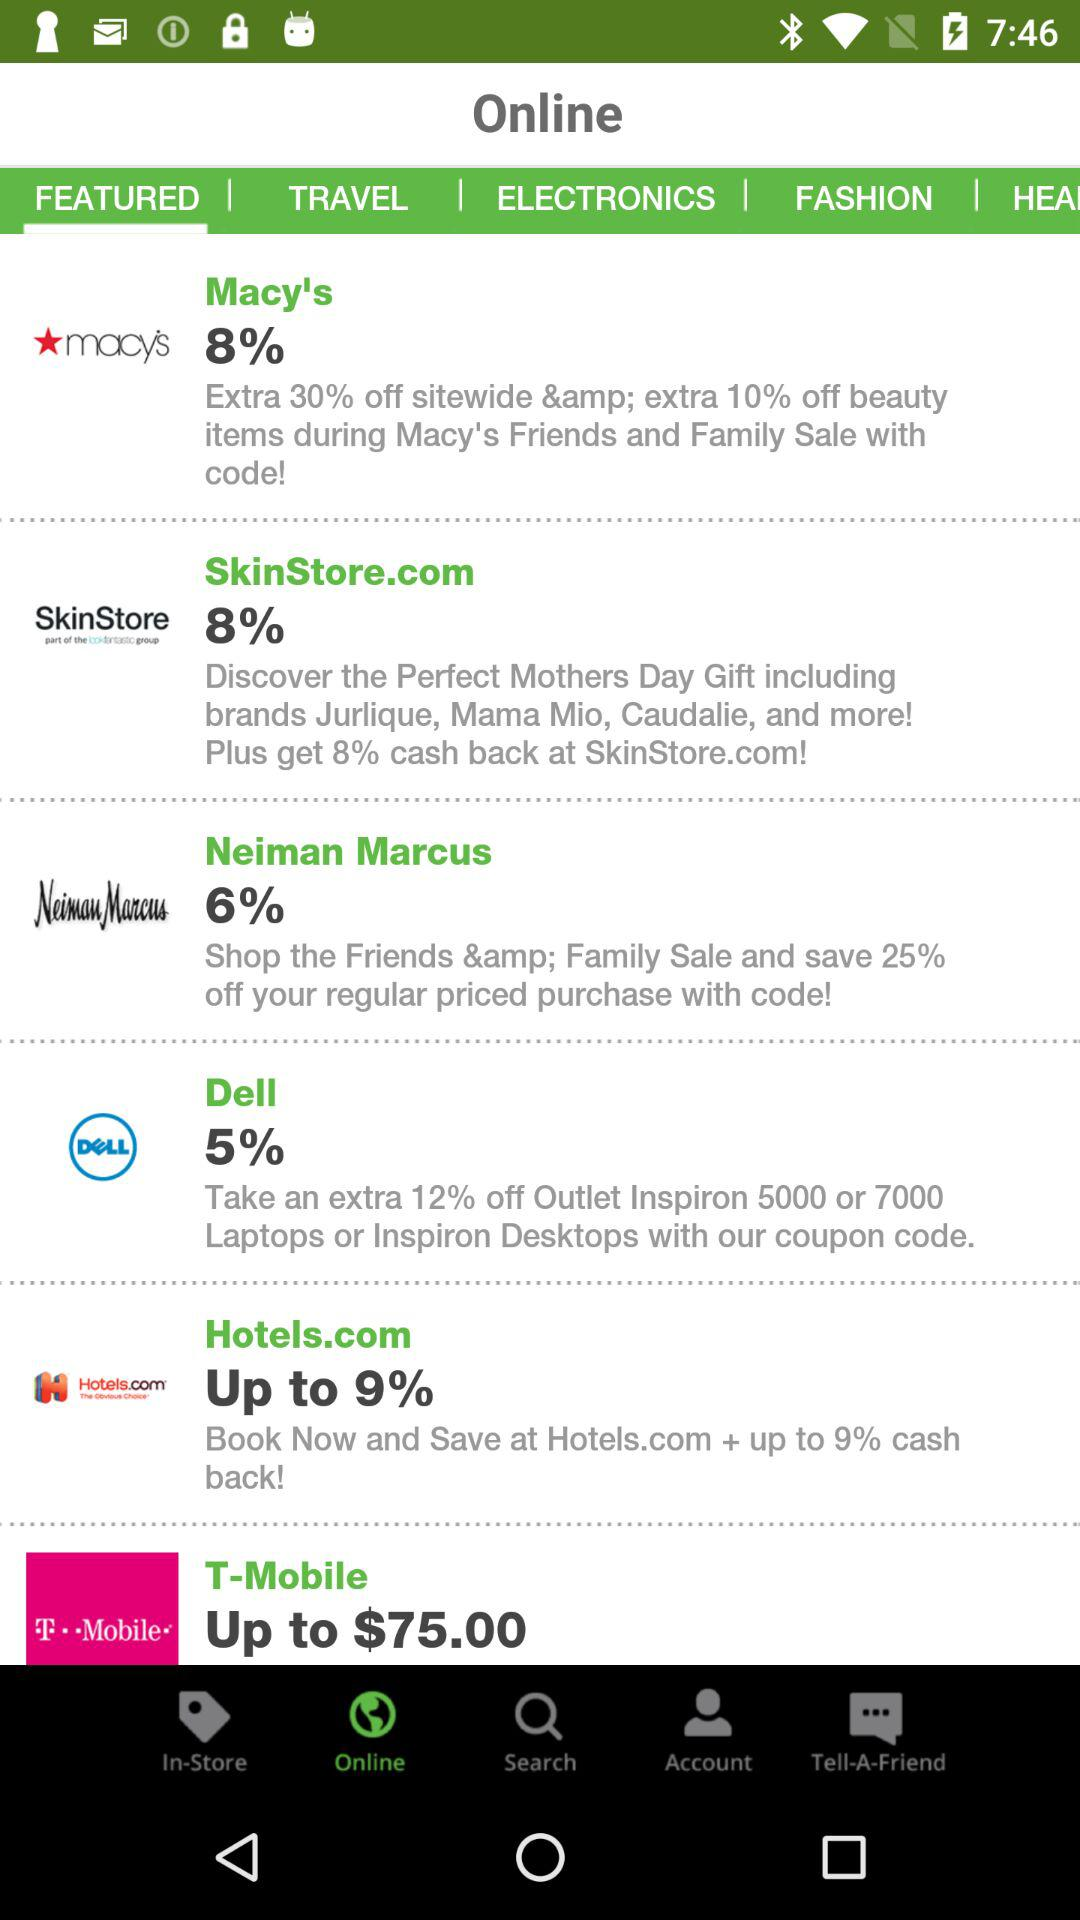How many notifications are there in "Account"?
When the provided information is insufficient, respond with <no answer>. <no answer> 